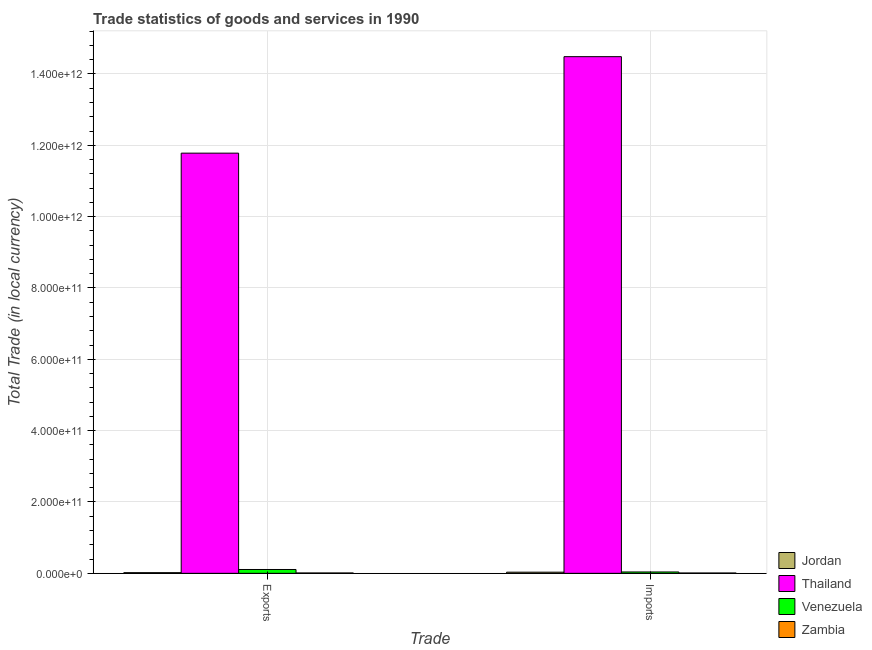How many different coloured bars are there?
Provide a succinct answer. 4. How many bars are there on the 2nd tick from the left?
Ensure brevity in your answer.  4. What is the label of the 2nd group of bars from the left?
Your response must be concise. Imports. What is the imports of goods and services in Venezuela?
Keep it short and to the point. 3.83e+09. Across all countries, what is the maximum export of goods and services?
Offer a very short reply. 1.18e+12. Across all countries, what is the minimum export of goods and services?
Your answer should be compact. 1.06e+09. In which country was the export of goods and services maximum?
Offer a terse response. Thailand. In which country was the export of goods and services minimum?
Provide a succinct answer. Zambia. What is the total imports of goods and services in the graph?
Provide a short and direct response. 1.46e+12. What is the difference between the imports of goods and services in Jordan and that in Zambia?
Your answer should be compact. 2.28e+09. What is the difference between the export of goods and services in Thailand and the imports of goods and services in Zambia?
Give a very brief answer. 1.18e+12. What is the average export of goods and services per country?
Your response must be concise. 2.98e+11. What is the difference between the imports of goods and services and export of goods and services in Thailand?
Ensure brevity in your answer.  2.71e+11. What is the ratio of the export of goods and services in Zambia to that in Thailand?
Provide a succinct answer. 0. What does the 1st bar from the left in Imports represents?
Keep it short and to the point. Jordan. What does the 2nd bar from the right in Imports represents?
Provide a succinct answer. Venezuela. How many bars are there?
Make the answer very short. 8. Are all the bars in the graph horizontal?
Offer a terse response. No. How many countries are there in the graph?
Make the answer very short. 4. What is the difference between two consecutive major ticks on the Y-axis?
Your answer should be very brief. 2.00e+11. Where does the legend appear in the graph?
Give a very brief answer. Bottom right. How are the legend labels stacked?
Provide a succinct answer. Vertical. What is the title of the graph?
Your response must be concise. Trade statistics of goods and services in 1990. Does "Bahamas" appear as one of the legend labels in the graph?
Provide a short and direct response. No. What is the label or title of the X-axis?
Give a very brief answer. Trade. What is the label or title of the Y-axis?
Offer a terse response. Total Trade (in local currency). What is the Total Trade (in local currency) of Jordan in Exports?
Offer a very short reply. 1.89e+09. What is the Total Trade (in local currency) of Thailand in Exports?
Ensure brevity in your answer.  1.18e+12. What is the Total Trade (in local currency) in Venezuela in Exports?
Offer a terse response. 1.08e+1. What is the Total Trade (in local currency) in Zambia in Exports?
Make the answer very short. 1.06e+09. What is the Total Trade (in local currency) of Jordan in Imports?
Your answer should be compact. 3.24e+09. What is the Total Trade (in local currency) of Thailand in Imports?
Your answer should be very brief. 1.45e+12. What is the Total Trade (in local currency) of Venezuela in Imports?
Your response must be concise. 3.83e+09. What is the Total Trade (in local currency) of Zambia in Imports?
Offer a very short reply. 9.62e+08. Across all Trade, what is the maximum Total Trade (in local currency) in Jordan?
Ensure brevity in your answer.  3.24e+09. Across all Trade, what is the maximum Total Trade (in local currency) in Thailand?
Make the answer very short. 1.45e+12. Across all Trade, what is the maximum Total Trade (in local currency) in Venezuela?
Ensure brevity in your answer.  1.08e+1. Across all Trade, what is the maximum Total Trade (in local currency) in Zambia?
Offer a very short reply. 1.06e+09. Across all Trade, what is the minimum Total Trade (in local currency) of Jordan?
Make the answer very short. 1.89e+09. Across all Trade, what is the minimum Total Trade (in local currency) of Thailand?
Provide a succinct answer. 1.18e+12. Across all Trade, what is the minimum Total Trade (in local currency) of Venezuela?
Your answer should be very brief. 3.83e+09. Across all Trade, what is the minimum Total Trade (in local currency) of Zambia?
Your answer should be very brief. 9.62e+08. What is the total Total Trade (in local currency) of Jordan in the graph?
Make the answer very short. 5.13e+09. What is the total Total Trade (in local currency) in Thailand in the graph?
Your answer should be very brief. 2.63e+12. What is the total Total Trade (in local currency) in Venezuela in the graph?
Offer a very short reply. 1.46e+1. What is the total Total Trade (in local currency) of Zambia in the graph?
Give a very brief answer. 2.02e+09. What is the difference between the Total Trade (in local currency) in Jordan in Exports and that in Imports?
Provide a short and direct response. -1.35e+09. What is the difference between the Total Trade (in local currency) of Thailand in Exports and that in Imports?
Keep it short and to the point. -2.71e+11. What is the difference between the Total Trade (in local currency) of Venezuela in Exports and that in Imports?
Provide a succinct answer. 6.96e+09. What is the difference between the Total Trade (in local currency) in Zambia in Exports and that in Imports?
Your answer should be compact. 1.02e+08. What is the difference between the Total Trade (in local currency) of Jordan in Exports and the Total Trade (in local currency) of Thailand in Imports?
Your answer should be very brief. -1.45e+12. What is the difference between the Total Trade (in local currency) of Jordan in Exports and the Total Trade (in local currency) of Venezuela in Imports?
Your response must be concise. -1.94e+09. What is the difference between the Total Trade (in local currency) of Jordan in Exports and the Total Trade (in local currency) of Zambia in Imports?
Offer a terse response. 9.28e+08. What is the difference between the Total Trade (in local currency) in Thailand in Exports and the Total Trade (in local currency) in Venezuela in Imports?
Your answer should be very brief. 1.17e+12. What is the difference between the Total Trade (in local currency) in Thailand in Exports and the Total Trade (in local currency) in Zambia in Imports?
Keep it short and to the point. 1.18e+12. What is the difference between the Total Trade (in local currency) in Venezuela in Exports and the Total Trade (in local currency) in Zambia in Imports?
Give a very brief answer. 9.83e+09. What is the average Total Trade (in local currency) of Jordan per Trade?
Make the answer very short. 2.57e+09. What is the average Total Trade (in local currency) in Thailand per Trade?
Provide a short and direct response. 1.31e+12. What is the average Total Trade (in local currency) in Venezuela per Trade?
Your answer should be very brief. 7.31e+09. What is the average Total Trade (in local currency) of Zambia per Trade?
Your response must be concise. 1.01e+09. What is the difference between the Total Trade (in local currency) in Jordan and Total Trade (in local currency) in Thailand in Exports?
Provide a succinct answer. -1.18e+12. What is the difference between the Total Trade (in local currency) of Jordan and Total Trade (in local currency) of Venezuela in Exports?
Keep it short and to the point. -8.90e+09. What is the difference between the Total Trade (in local currency) of Jordan and Total Trade (in local currency) of Zambia in Exports?
Provide a short and direct response. 8.26e+08. What is the difference between the Total Trade (in local currency) of Thailand and Total Trade (in local currency) of Venezuela in Exports?
Your response must be concise. 1.17e+12. What is the difference between the Total Trade (in local currency) in Thailand and Total Trade (in local currency) in Zambia in Exports?
Ensure brevity in your answer.  1.18e+12. What is the difference between the Total Trade (in local currency) of Venezuela and Total Trade (in local currency) of Zambia in Exports?
Make the answer very short. 9.73e+09. What is the difference between the Total Trade (in local currency) of Jordan and Total Trade (in local currency) of Thailand in Imports?
Provide a short and direct response. -1.45e+12. What is the difference between the Total Trade (in local currency) in Jordan and Total Trade (in local currency) in Venezuela in Imports?
Your answer should be compact. -5.90e+08. What is the difference between the Total Trade (in local currency) in Jordan and Total Trade (in local currency) in Zambia in Imports?
Provide a short and direct response. 2.28e+09. What is the difference between the Total Trade (in local currency) in Thailand and Total Trade (in local currency) in Venezuela in Imports?
Ensure brevity in your answer.  1.44e+12. What is the difference between the Total Trade (in local currency) in Thailand and Total Trade (in local currency) in Zambia in Imports?
Offer a terse response. 1.45e+12. What is the difference between the Total Trade (in local currency) in Venezuela and Total Trade (in local currency) in Zambia in Imports?
Your answer should be compact. 2.87e+09. What is the ratio of the Total Trade (in local currency) in Jordan in Exports to that in Imports?
Provide a succinct answer. 0.58. What is the ratio of the Total Trade (in local currency) in Thailand in Exports to that in Imports?
Your answer should be very brief. 0.81. What is the ratio of the Total Trade (in local currency) of Venezuela in Exports to that in Imports?
Provide a short and direct response. 2.81. What is the ratio of the Total Trade (in local currency) of Zambia in Exports to that in Imports?
Make the answer very short. 1.11. What is the difference between the highest and the second highest Total Trade (in local currency) in Jordan?
Keep it short and to the point. 1.35e+09. What is the difference between the highest and the second highest Total Trade (in local currency) of Thailand?
Offer a very short reply. 2.71e+11. What is the difference between the highest and the second highest Total Trade (in local currency) in Venezuela?
Your answer should be very brief. 6.96e+09. What is the difference between the highest and the second highest Total Trade (in local currency) in Zambia?
Keep it short and to the point. 1.02e+08. What is the difference between the highest and the lowest Total Trade (in local currency) of Jordan?
Provide a succinct answer. 1.35e+09. What is the difference between the highest and the lowest Total Trade (in local currency) in Thailand?
Your answer should be compact. 2.71e+11. What is the difference between the highest and the lowest Total Trade (in local currency) in Venezuela?
Offer a very short reply. 6.96e+09. What is the difference between the highest and the lowest Total Trade (in local currency) of Zambia?
Keep it short and to the point. 1.02e+08. 